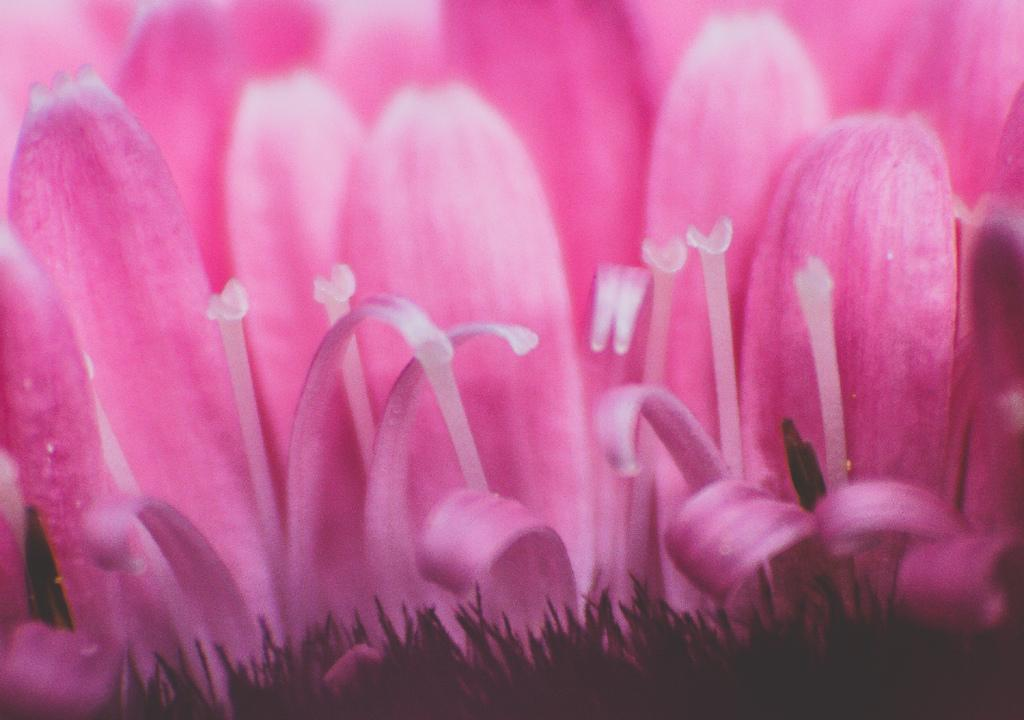What type of flowers can be seen in the image? There are pink color flowers in the image. What type of locket is hanging from the flowers in the image? There is no locket present in the image; it only features pink color flowers. What relation do the flowers have with the field in the image? There is no field present in the image, only pink color flowers. 